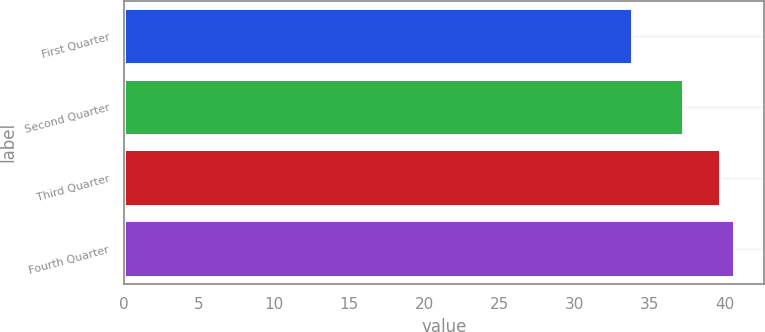Convert chart. <chart><loc_0><loc_0><loc_500><loc_500><bar_chart><fcel>First Quarter<fcel>Second Quarter<fcel>Third Quarter<fcel>Fourth Quarter<nl><fcel>33.84<fcel>37.25<fcel>39.67<fcel>40.61<nl></chart> 